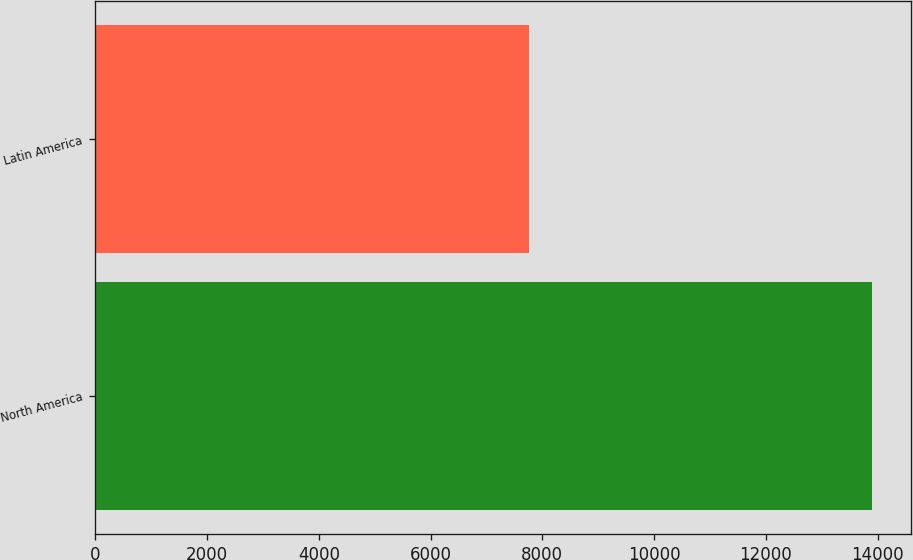Convert chart to OTSL. <chart><loc_0><loc_0><loc_500><loc_500><bar_chart><fcel>North America<fcel>Latin America<nl><fcel>13897<fcel>7754<nl></chart> 